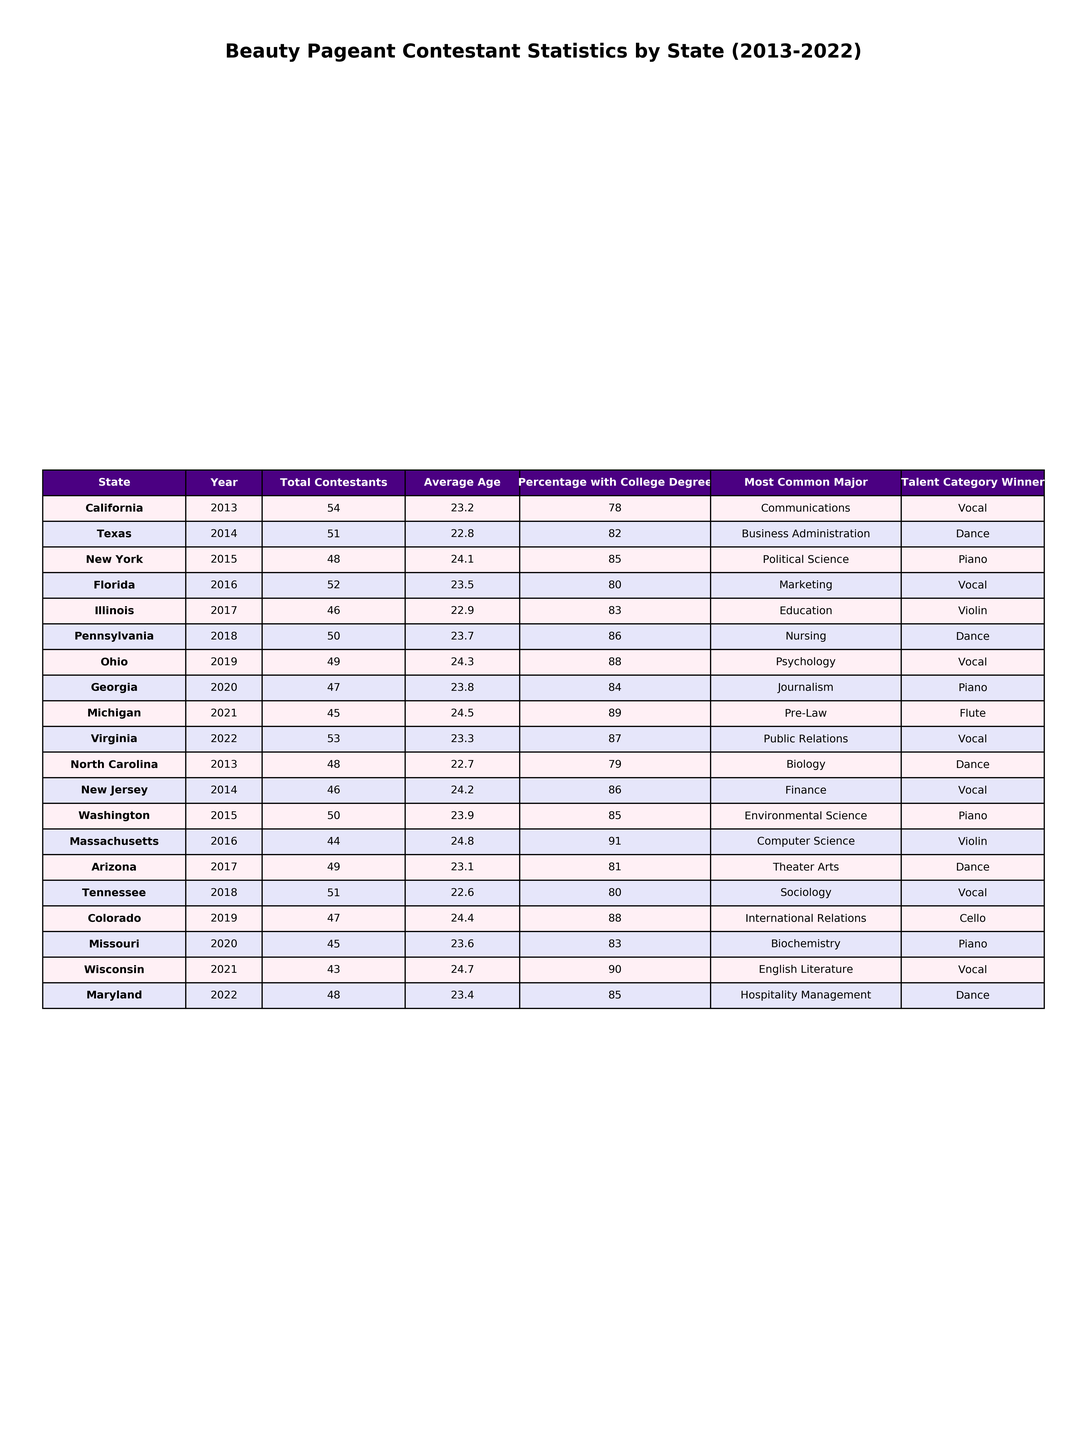What was the average age of contestants from California in 2013? The table shows that the average age of contestants from California in 2013 was 23.2 years.
Answer: 23.2 Which state had the highest percentage of contestants with a college degree in 2018? According to the table, Pennsylvania had the highest percentage with 86% in 2018.
Answer: Pennsylvania What is the total number of contestants from New York and Florida combined? From the table, New York had 48 contestants in 2015 while Florida had 52 in 2016. Adding them gives 48 + 52 = 100.
Answer: 100 In which year did Michigan have the largest average age of contestants? The table indicates that Michigan had an average age of 24.5 in 2021, which is the highest recorded.
Answer: 2021 Was the most common major for contestants in Virginia in 2022 Public Relations? Yes, according to the table, the most common major in Virginia in 2022 was Public Relations.
Answer: Yes What is the average percentage of college degrees for contestants from 2013 to 2022? To find the average, sum all percentage values (78 + 82 + 85 + 80 + 83 + 86 + 88 + 84 + 89 + 87 + 79 + 86 + 85 + 91 + 81 + 80 + 88 + 83 + 90 + 85) = 1719, then divide by 20. This gives an average of 1719 / 20 = 85.95%.
Answer: 85.95% What talent category was most commonly won by contestants from Ohio? The table reveals that the talent category winner for Ohio was Vocal.
Answer: Vocal Identify the state with the least number of contestants in any given year from 2013 to 2022. The table shows that Wisconsin had the least number of contestants with 43 in 2021.
Answer: Wisconsin How many years had the average age of contestants exceeded 24? The table shows that in 2015, 2021, and 2022, the average age was above 24. This amounts to 3 years.
Answer: 3 Which state exhibited the most consistent percentage of college degrees across the years? After examination, Pennsylvania has consistent values close to 86% and 87% in consecutive years, indicating less variability.
Answer: Pennsylvania 